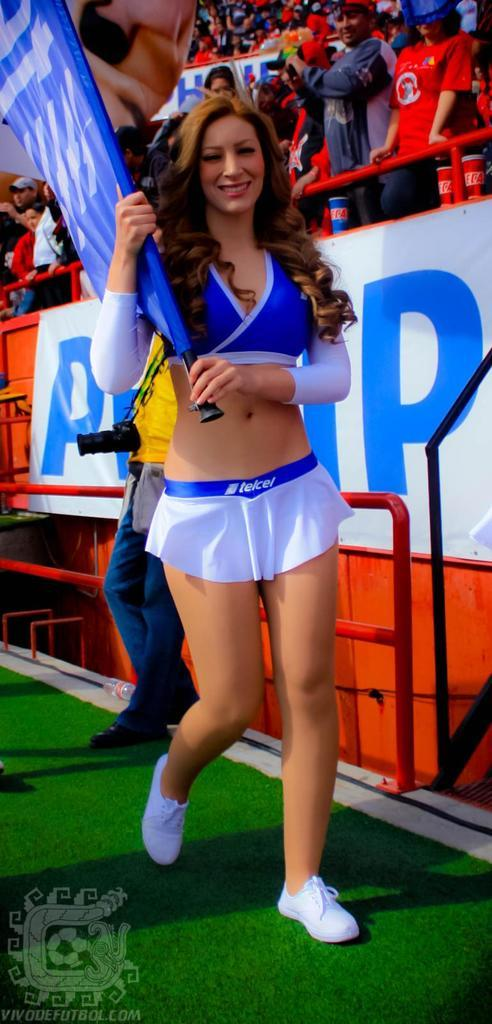<image>
Write a terse but informative summary of the picture. A cheerleader holding a flag and wearing a Telcel skirt. 